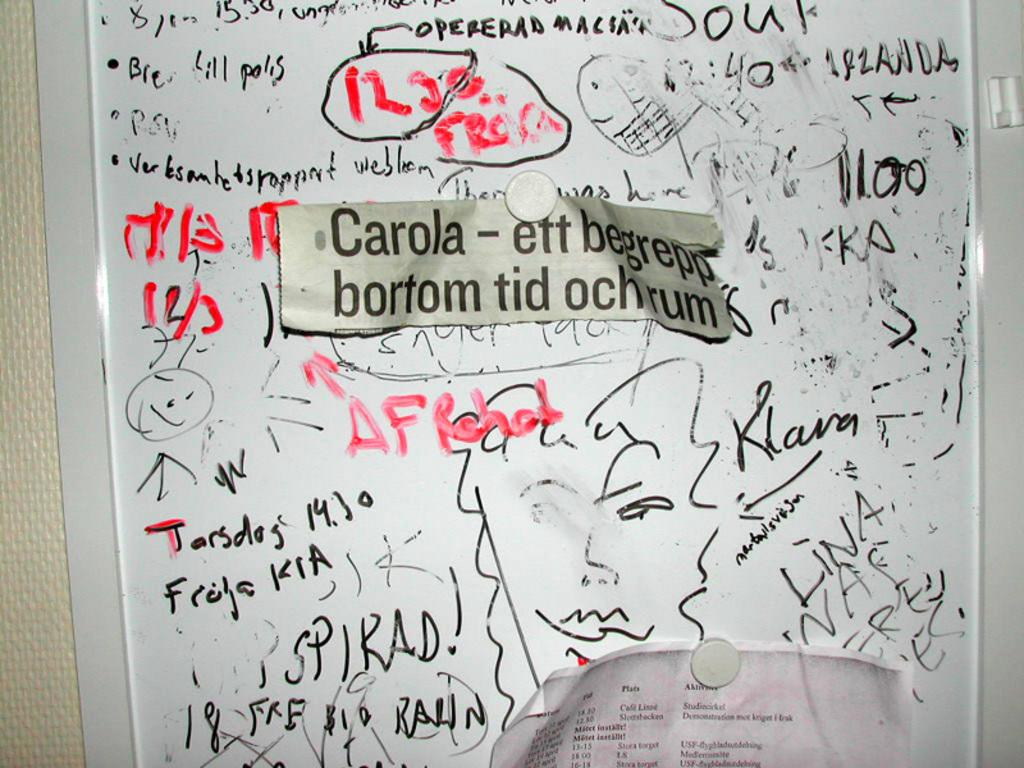<image>
Give a short and clear explanation of the subsequent image. White board which has a label saying "Carola". 